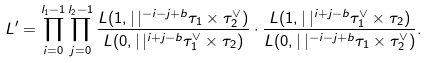<formula> <loc_0><loc_0><loc_500><loc_500>L ^ { \prime } = \prod _ { i = 0 } ^ { l _ { 1 } - 1 } \prod _ { j = 0 } ^ { l _ { 2 } - 1 } \frac { L ( 1 , | \, | ^ { - i - j + b } \tau _ { 1 } \times \tau _ { 2 } ^ { \vee } ) } { L ( 0 , | \, | ^ { i + j - b } \tau _ { 1 } ^ { \vee } \times \tau _ { 2 } ) } \cdot \frac { L ( 1 , | \, | ^ { i + j - b } \tau _ { 1 } ^ { \vee } \times \tau _ { 2 } ) } { L ( 0 , | \, | ^ { - i - j + b } \tau _ { 1 } \times \tau _ { 2 } ^ { \vee } ) } .</formula> 